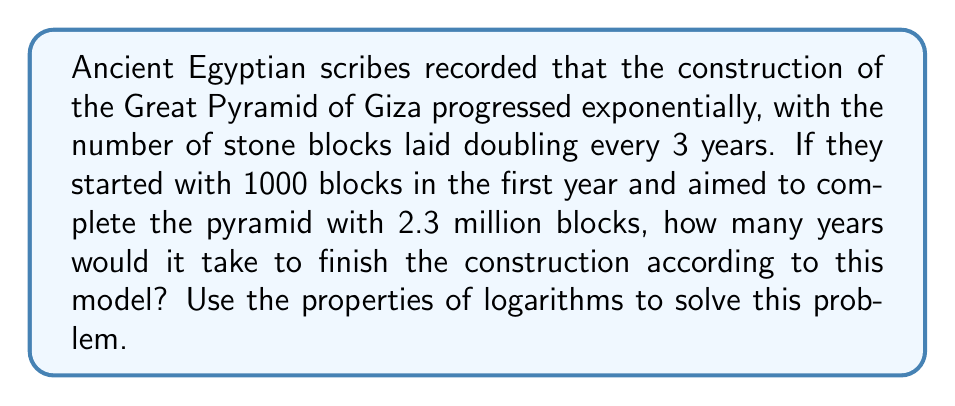Could you help me with this problem? Let's approach this step-by-step using logarithms:

1) Let $t$ be the number of years required to complete the pyramid.

2) We can express the number of blocks after $t$ years as:

   $1000 \cdot 2^{t/3} = 2,300,000$

3) Dividing both sides by 1000:

   $2^{t/3} = 2300$

4) Taking the logarithm (base 2) of both sides:

   $\log_2(2^{t/3}) = \log_2(2300)$

5) Using the logarithm property $\log_a(a^x) = x$:

   $\frac{t}{3} = \log_2(2300)$

6) Multiply both sides by 3:

   $t = 3 \log_2(2300)$

7) We can change the base of the logarithm to 10 using the change of base formula:

   $t = 3 \cdot \frac{\log_{10}(2300)}{\log_{10}(2)}$

8) Calculating this:

   $t \approx 3 \cdot \frac{3.36173}{0.30103} \approx 33.5$ years

Therefore, according to this model, it would take approximately 33.5 years to complete the Great Pyramid.
Answer: 33.5 years 